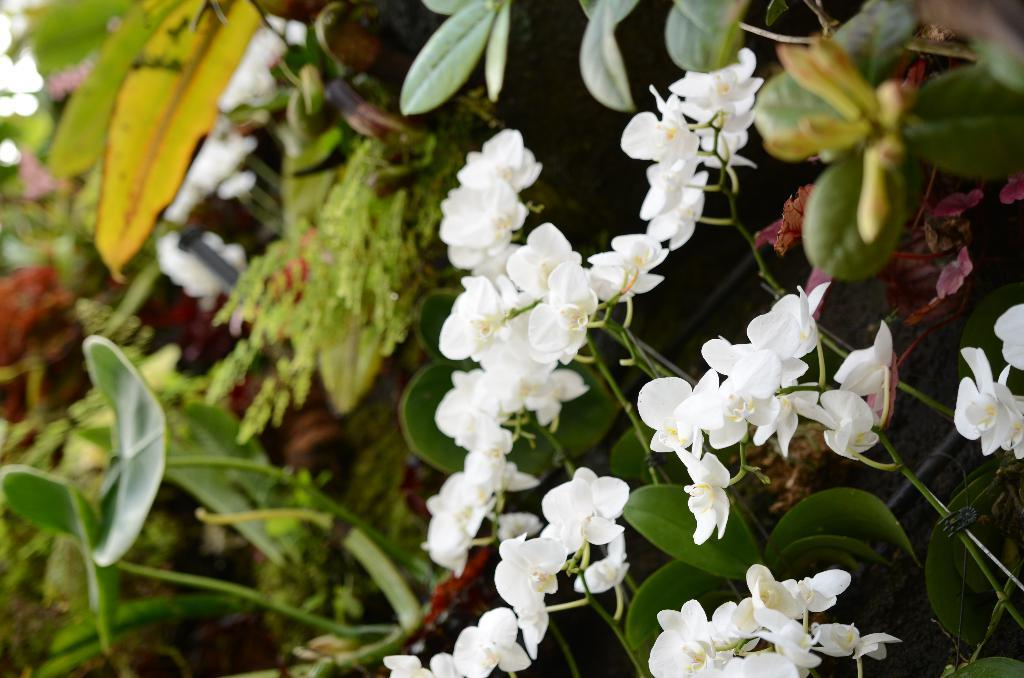What is present in the image? There are flowers in the image. What are the flowers on? The flowers are on plants. What color are the flowers? The flowers are white in color. What else can be seen in the background of the image? There are more plants visible in the background of the image. What type of treatment is being administered to the flowers in the image? There is no treatment being administered to the flowers in the image; they are simply growing on plants. 